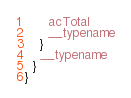<code> <loc_0><loc_0><loc_500><loc_500><_JavaScript_>      acTotal
      __typename
    }
    __typename
  }
}</code> 